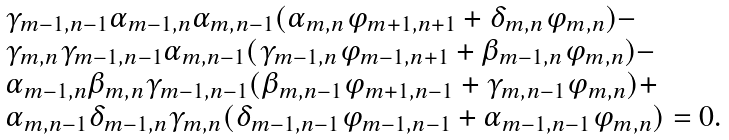Convert formula to latex. <formula><loc_0><loc_0><loc_500><loc_500>\begin{array} { l } \gamma _ { m - 1 , n - 1 } \alpha _ { m - 1 , n } \alpha _ { m , n - 1 } ( \alpha _ { m , n } \varphi _ { m + 1 , n + 1 } + \delta _ { m , n } \varphi _ { m , n } ) - \\ \gamma _ { m , n } \gamma _ { m - 1 , n - 1 } \alpha _ { m , n - 1 } ( \gamma _ { m - 1 , n } \varphi _ { m - 1 , n + 1 } + \beta _ { m - 1 , n } \varphi _ { m , n } ) - \\ \alpha _ { m - 1 , n } \beta _ { m , n } \gamma _ { m - 1 , n - 1 } ( \beta _ { m , n - 1 } \varphi _ { m + 1 , n - 1 } + \gamma _ { m , n - 1 } \varphi _ { m , n } ) + \\ \alpha _ { m , n - 1 } \delta _ { m - 1 , n } \gamma _ { m , n } ( \delta _ { m - 1 , n - 1 } \varphi _ { m - 1 , n - 1 } + \alpha _ { m - 1 , n - 1 } \varphi _ { m , n } ) = 0 . \end{array}</formula> 